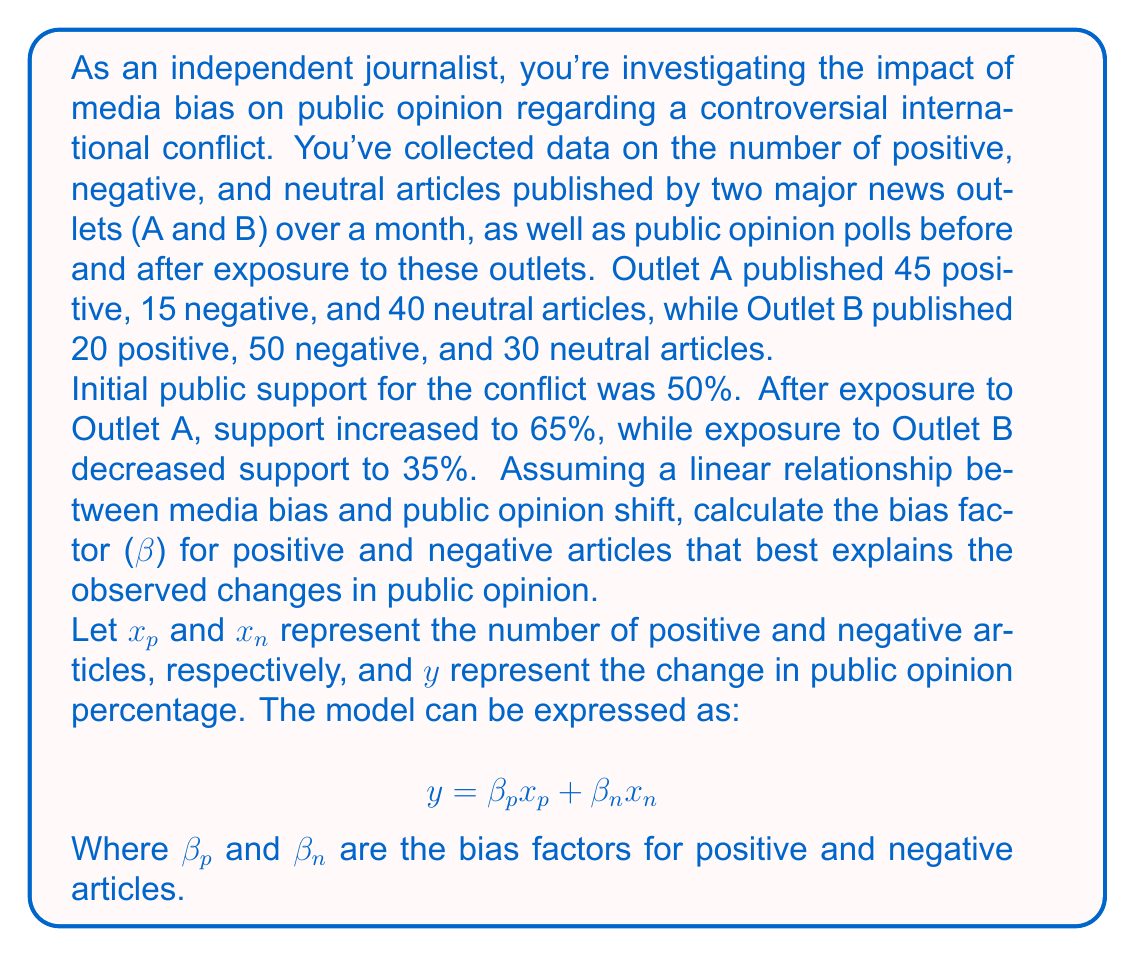Show me your answer to this math problem. To solve this problem, we'll follow these steps:

1. Set up a system of equations using the given data.
2. Solve the system of equations to find the bias factors.

Step 1: Set up the system of equations

For Outlet A:
$$ 15 = \beta_p(45) + \beta_n(15) $$

For Outlet B:
$$ -15 = \beta_p(20) + \beta_n(50) $$

Step 2: Solve the system of equations

Let's multiply the first equation by 2 and the second equation by 3 to eliminate $\beta_p$:

$$ 30 = \beta_p(90) + \beta_n(30) $$
$$ -45 = \beta_p(60) + \beta_n(150) $$

Subtracting the second equation from the first:

$$ 75 = \beta_p(30) - \beta_n(120) $$

Now we have:

$$ 15 = \beta_p(45) + \beta_n(15) $$ (Equation 1)
$$ 75 = \beta_p(30) - \beta_n(120) $$ (Equation 2)

Multiply Equation 1 by 2:
$$ 30 = \beta_p(90) + \beta_n(30) $$ (Equation 3)

Subtract Equation 2 from Equation 3:
$$ -45 = \beta_p(60) + \beta_n(150) $$

Divide by 30:
$$ -1.5 = \beta_p(2) + \beta_n(5) $$ (Equation 4)

Now we have two equations with two unknowns:

$$ 15 = \beta_p(45) + \beta_n(15) $$ (Equation 1)
$$ -1.5 = \beta_p(2) + \beta_n(5) $$ (Equation 4)

Multiply Equation 4 by 3:
$$ -4.5 = \beta_p(6) + \beta_n(15) $$ (Equation 5)

Subtract Equation 5 from Equation 1:
$$ 19.5 = \beta_p(39) $$

$$ \beta_p = \frac{19.5}{39} = 0.5 $$

Substitute $\beta_p = 0.5$ into Equation 1:

$$ 15 = 0.5(45) + \beta_n(15) $$
$$ 15 = 22.5 + \beta_n(15) $$
$$ -7.5 = \beta_n(15) $$

$$ \beta_n = \frac{-7.5}{15} = -0.5 $$

Therefore, the bias factors are:
$\beta_p = 0.5$ and $\beta_n = -0.5$
Answer: $\beta_p = 0.5$, $\beta_n = -0.5$ 